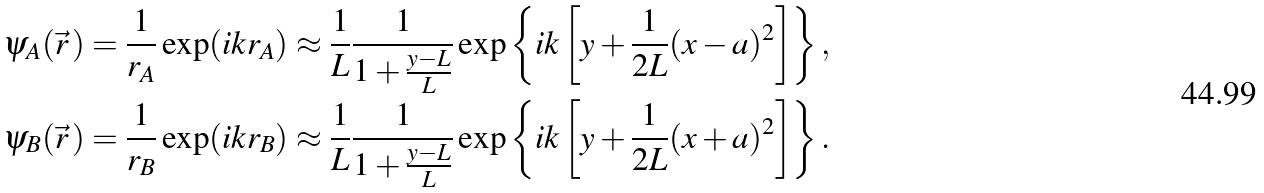Convert formula to latex. <formula><loc_0><loc_0><loc_500><loc_500>\psi _ { A } ( \vec { r } \, ) & = \frac { 1 } { r _ { A } } \exp ( i k r _ { A } ) \approx \frac { 1 } { L } \frac { 1 } { 1 + \frac { y - L } { L } } \exp \left \{ i k \left [ y + \frac { 1 } { 2 L } ( x - a ) ^ { 2 } \right ] \right \} , \\ \psi _ { B } ( \vec { r } \, ) & = \frac { 1 } { r _ { B } } \exp ( i k r _ { B } ) \approx \frac { 1 } { L } \frac { 1 } { 1 + \frac { y - L } { L } } \exp \left \{ i k \left [ y + \frac { 1 } { 2 L } ( x + a ) ^ { 2 } \right ] \right \} .</formula> 